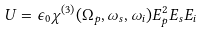<formula> <loc_0><loc_0><loc_500><loc_500>U = \epsilon _ { 0 } \chi ^ { ( 3 ) } ( \Omega _ { p } , \omega _ { s } , \omega _ { i } ) E _ { p } ^ { 2 } E _ { s } E _ { i }</formula> 